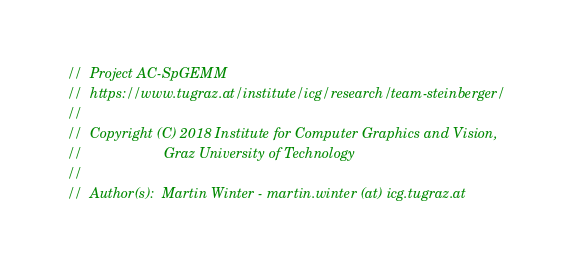Convert code to text. <code><loc_0><loc_0><loc_500><loc_500><_Cuda_>//  Project AC-SpGEMM
//  https://www.tugraz.at/institute/icg/research/team-steinberger/
//
//  Copyright (C) 2018 Institute for Computer Graphics and Vision,
//                     Graz University of Technology
//
//  Author(s):  Martin Winter - martin.winter (at) icg.tugraz.at</code> 